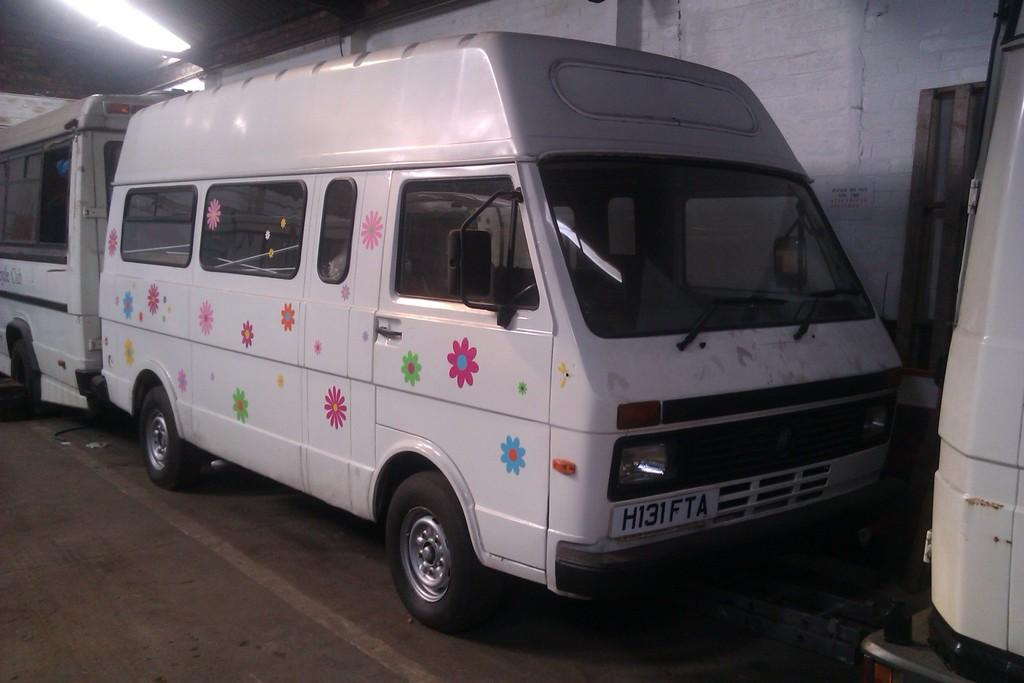What is the main subject of the image? The main subject of the image is a group of vehicles. How are the vehicles positioned in the image? The vehicles are parked on the ground. What can be seen in the background of the image? There are windows visible in the background of the image. What type of paste is being used to hold the alarm in the image? There is no paste or alarm present in the image; it features a group of vehicles parked on the ground with windows visible in the background. 